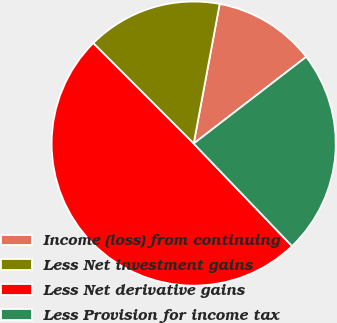Convert chart. <chart><loc_0><loc_0><loc_500><loc_500><pie_chart><fcel>Income (loss) from continuing<fcel>Less Net investment gains<fcel>Less Net derivative gains<fcel>Less Provision for income tax<nl><fcel>11.62%<fcel>15.43%<fcel>49.67%<fcel>23.28%<nl></chart> 